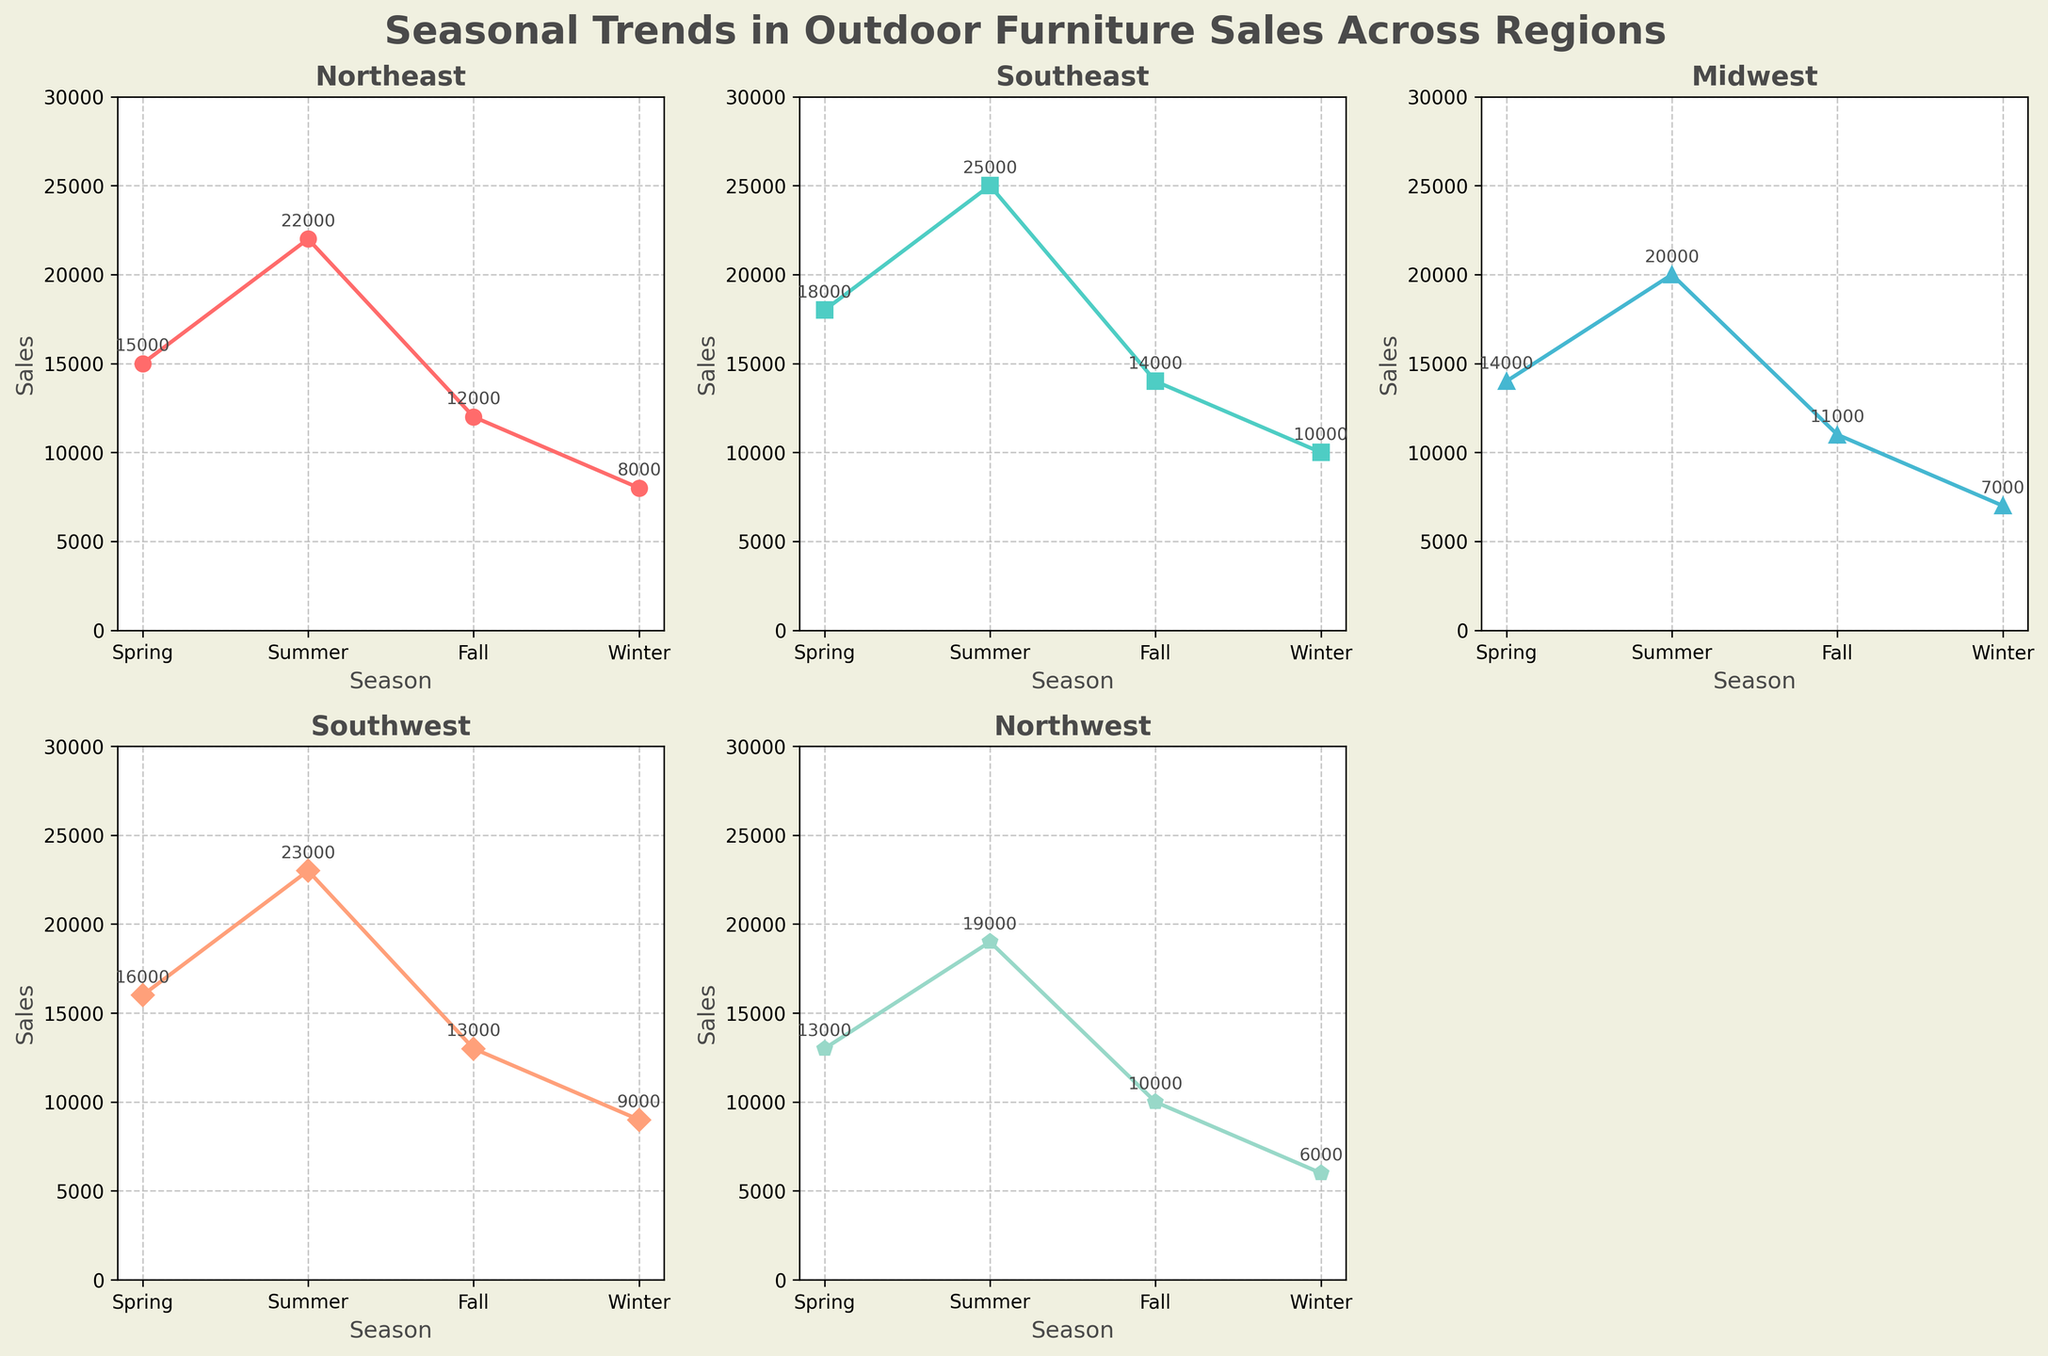How many seasons are depicted in the charts? The x-axis of each subplot is labeled with the four different seasons: Spring, Summer, Fall, and Winter.
Answer: 4 Which region has the highest outdoor furniture sales in the Summer? By looking at the peak values in the plots for all regions during Summer, the Southeast region shows the highest sales number at 25,000.
Answer: Southeast What is the difference in outdoor furniture sales between the Winter and Summer seasons in the Midwest? The sale value for Winter in the Midwest is 7,000, and for Summer, it is 20,000. The difference is 20,000 - 7,000 = 13,000.
Answer: 13,000 Which region has the smallest drop in sales from Spring to Fall? Comparing the sales values in Spring and Fall for all regions, we observe that the Southeast region has the smallest drop from 18,000 in Spring to 14,000 in Fall, which is a decrease of 4,000.
Answer: Southeast What is the average sales value of outdoor furniture in the Northwest across all four seasons? Summing up the sales figures for the Northwest region across the seasons (13,000 + 19,000 + 10,000 + 6,000) gives 48,000. Dividing this by the number of seasons (4) gives an average of 48,000 / 4 = 12,000.
Answer: 12,000 Which season generally has the lowest sales figures for all regions? Observing the plots for all regions, every region reports its lowest sales figures during Winter.
Answer: Winter How much higher are the Spring sales in the Southeast compared to the Midwest? The sales figures in Spring for the Southeast are 18,000 and for the Midwest, they are 14,000. The difference is 18,000 - 14,000 = 4,000.
Answer: 4,000 Do any regions show an increasing trend in sales from Spring to Winter? Reviewing all regional plots, none display an overall increasing trend from Spring to Winter. All show a decrease in sales from Spring to Winter.
Answer: No What is the sum of all outdoor furniture sales across all regions in the Fall? Summing the Fall sales values across all regions: 12,000 (Northeast) + 14,000 (Southeast) + 11,000 (Midwest) + 13,000 (Southwest) + 10,000 (Northwest) equals 60,000.
Answer: 60,000 